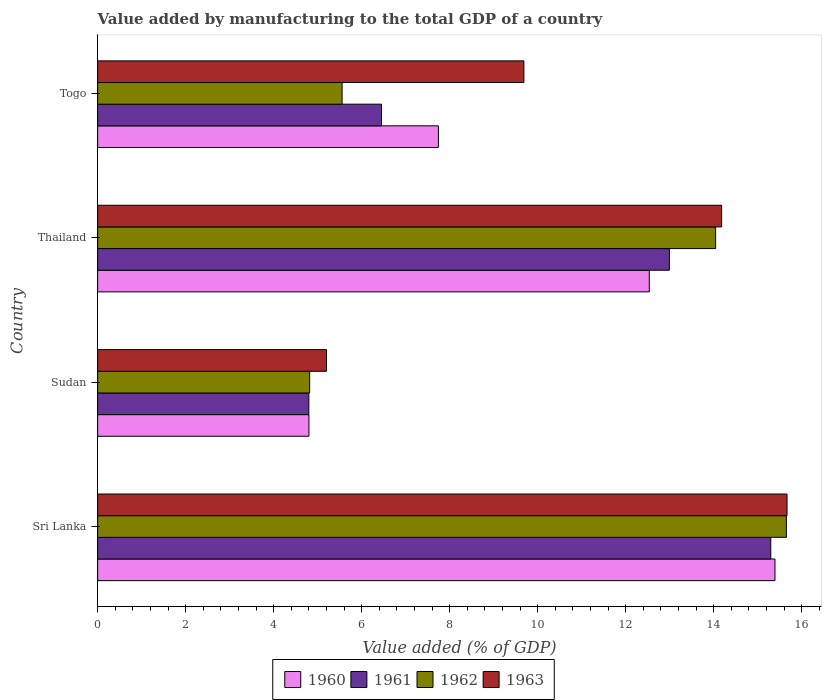How many different coloured bars are there?
Your answer should be compact. 4. Are the number of bars per tick equal to the number of legend labels?
Make the answer very short. Yes. Are the number of bars on each tick of the Y-axis equal?
Ensure brevity in your answer.  Yes. How many bars are there on the 1st tick from the top?
Offer a very short reply. 4. How many bars are there on the 4th tick from the bottom?
Give a very brief answer. 4. What is the label of the 1st group of bars from the top?
Offer a very short reply. Togo. In how many cases, is the number of bars for a given country not equal to the number of legend labels?
Keep it short and to the point. 0. What is the value added by manufacturing to the total GDP in 1960 in Sudan?
Give a very brief answer. 4.8. Across all countries, what is the maximum value added by manufacturing to the total GDP in 1963?
Offer a terse response. 15.67. Across all countries, what is the minimum value added by manufacturing to the total GDP in 1960?
Ensure brevity in your answer.  4.8. In which country was the value added by manufacturing to the total GDP in 1962 maximum?
Provide a short and direct response. Sri Lanka. In which country was the value added by manufacturing to the total GDP in 1962 minimum?
Keep it short and to the point. Sudan. What is the total value added by manufacturing to the total GDP in 1962 in the graph?
Provide a short and direct response. 40.07. What is the difference between the value added by manufacturing to the total GDP in 1963 in Sudan and that in Togo?
Ensure brevity in your answer.  -4.49. What is the difference between the value added by manufacturing to the total GDP in 1961 in Sudan and the value added by manufacturing to the total GDP in 1962 in Sri Lanka?
Make the answer very short. -10.85. What is the average value added by manufacturing to the total GDP in 1963 per country?
Keep it short and to the point. 11.18. What is the difference between the value added by manufacturing to the total GDP in 1961 and value added by manufacturing to the total GDP in 1960 in Thailand?
Your response must be concise. 0.46. In how many countries, is the value added by manufacturing to the total GDP in 1960 greater than 3.2 %?
Offer a terse response. 4. What is the ratio of the value added by manufacturing to the total GDP in 1961 in Sudan to that in Thailand?
Offer a terse response. 0.37. Is the value added by manufacturing to the total GDP in 1962 in Sri Lanka less than that in Sudan?
Ensure brevity in your answer.  No. What is the difference between the highest and the second highest value added by manufacturing to the total GDP in 1960?
Offer a terse response. 2.86. What is the difference between the highest and the lowest value added by manufacturing to the total GDP in 1960?
Make the answer very short. 10.59. In how many countries, is the value added by manufacturing to the total GDP in 1962 greater than the average value added by manufacturing to the total GDP in 1962 taken over all countries?
Your answer should be compact. 2. Is the sum of the value added by manufacturing to the total GDP in 1961 in Sri Lanka and Sudan greater than the maximum value added by manufacturing to the total GDP in 1960 across all countries?
Provide a succinct answer. Yes. Is it the case that in every country, the sum of the value added by manufacturing to the total GDP in 1962 and value added by manufacturing to the total GDP in 1960 is greater than the sum of value added by manufacturing to the total GDP in 1961 and value added by manufacturing to the total GDP in 1963?
Provide a short and direct response. No. What does the 4th bar from the top in Togo represents?
Make the answer very short. 1960. What does the 3rd bar from the bottom in Sri Lanka represents?
Your answer should be very brief. 1962. Is it the case that in every country, the sum of the value added by manufacturing to the total GDP in 1963 and value added by manufacturing to the total GDP in 1961 is greater than the value added by manufacturing to the total GDP in 1960?
Provide a short and direct response. Yes. How many countries are there in the graph?
Your answer should be very brief. 4. What is the difference between two consecutive major ticks on the X-axis?
Your answer should be very brief. 2. Does the graph contain any zero values?
Provide a short and direct response. No. How many legend labels are there?
Provide a succinct answer. 4. What is the title of the graph?
Your response must be concise. Value added by manufacturing to the total GDP of a country. What is the label or title of the X-axis?
Your response must be concise. Value added (% of GDP). What is the label or title of the Y-axis?
Ensure brevity in your answer.  Country. What is the Value added (% of GDP) in 1960 in Sri Lanka?
Give a very brief answer. 15.39. What is the Value added (% of GDP) of 1961 in Sri Lanka?
Ensure brevity in your answer.  15.3. What is the Value added (% of GDP) of 1962 in Sri Lanka?
Offer a very short reply. 15.65. What is the Value added (% of GDP) of 1963 in Sri Lanka?
Your answer should be compact. 15.67. What is the Value added (% of GDP) in 1960 in Sudan?
Your answer should be very brief. 4.8. What is the Value added (% of GDP) of 1961 in Sudan?
Your answer should be compact. 4.8. What is the Value added (% of GDP) in 1962 in Sudan?
Offer a terse response. 4.82. What is the Value added (% of GDP) in 1963 in Sudan?
Offer a terse response. 5.2. What is the Value added (% of GDP) in 1960 in Thailand?
Provide a short and direct response. 12.54. What is the Value added (% of GDP) of 1961 in Thailand?
Provide a short and direct response. 12.99. What is the Value added (% of GDP) of 1962 in Thailand?
Offer a terse response. 14.04. What is the Value added (% of GDP) in 1963 in Thailand?
Provide a succinct answer. 14.18. What is the Value added (% of GDP) in 1960 in Togo?
Offer a very short reply. 7.74. What is the Value added (% of GDP) of 1961 in Togo?
Your answer should be very brief. 6.45. What is the Value added (% of GDP) in 1962 in Togo?
Make the answer very short. 5.56. What is the Value added (% of GDP) in 1963 in Togo?
Your response must be concise. 9.69. Across all countries, what is the maximum Value added (% of GDP) of 1960?
Provide a succinct answer. 15.39. Across all countries, what is the maximum Value added (% of GDP) of 1961?
Offer a very short reply. 15.3. Across all countries, what is the maximum Value added (% of GDP) of 1962?
Ensure brevity in your answer.  15.65. Across all countries, what is the maximum Value added (% of GDP) in 1963?
Offer a terse response. 15.67. Across all countries, what is the minimum Value added (% of GDP) in 1960?
Provide a succinct answer. 4.8. Across all countries, what is the minimum Value added (% of GDP) in 1961?
Provide a succinct answer. 4.8. Across all countries, what is the minimum Value added (% of GDP) of 1962?
Offer a terse response. 4.82. Across all countries, what is the minimum Value added (% of GDP) in 1963?
Offer a very short reply. 5.2. What is the total Value added (% of GDP) in 1960 in the graph?
Your answer should be compact. 40.48. What is the total Value added (% of GDP) in 1961 in the graph?
Offer a very short reply. 39.54. What is the total Value added (% of GDP) in 1962 in the graph?
Give a very brief answer. 40.07. What is the total Value added (% of GDP) of 1963 in the graph?
Offer a terse response. 44.74. What is the difference between the Value added (% of GDP) in 1960 in Sri Lanka and that in Sudan?
Keep it short and to the point. 10.59. What is the difference between the Value added (% of GDP) in 1961 in Sri Lanka and that in Sudan?
Your answer should be very brief. 10.5. What is the difference between the Value added (% of GDP) in 1962 in Sri Lanka and that in Sudan?
Your response must be concise. 10.83. What is the difference between the Value added (% of GDP) in 1963 in Sri Lanka and that in Sudan?
Keep it short and to the point. 10.47. What is the difference between the Value added (% of GDP) of 1960 in Sri Lanka and that in Thailand?
Keep it short and to the point. 2.86. What is the difference between the Value added (% of GDP) in 1961 in Sri Lanka and that in Thailand?
Offer a very short reply. 2.3. What is the difference between the Value added (% of GDP) of 1962 in Sri Lanka and that in Thailand?
Provide a succinct answer. 1.61. What is the difference between the Value added (% of GDP) in 1963 in Sri Lanka and that in Thailand?
Keep it short and to the point. 1.49. What is the difference between the Value added (% of GDP) in 1960 in Sri Lanka and that in Togo?
Your answer should be very brief. 7.65. What is the difference between the Value added (% of GDP) in 1961 in Sri Lanka and that in Togo?
Offer a very short reply. 8.85. What is the difference between the Value added (% of GDP) in 1962 in Sri Lanka and that in Togo?
Offer a very short reply. 10.1. What is the difference between the Value added (% of GDP) of 1963 in Sri Lanka and that in Togo?
Offer a very short reply. 5.98. What is the difference between the Value added (% of GDP) in 1960 in Sudan and that in Thailand?
Make the answer very short. -7.73. What is the difference between the Value added (% of GDP) of 1961 in Sudan and that in Thailand?
Your answer should be compact. -8.19. What is the difference between the Value added (% of GDP) in 1962 in Sudan and that in Thailand?
Provide a short and direct response. -9.23. What is the difference between the Value added (% of GDP) of 1963 in Sudan and that in Thailand?
Your response must be concise. -8.98. What is the difference between the Value added (% of GDP) of 1960 in Sudan and that in Togo?
Your response must be concise. -2.94. What is the difference between the Value added (% of GDP) in 1961 in Sudan and that in Togo?
Ensure brevity in your answer.  -1.65. What is the difference between the Value added (% of GDP) of 1962 in Sudan and that in Togo?
Give a very brief answer. -0.74. What is the difference between the Value added (% of GDP) of 1963 in Sudan and that in Togo?
Your answer should be very brief. -4.49. What is the difference between the Value added (% of GDP) of 1960 in Thailand and that in Togo?
Provide a succinct answer. 4.79. What is the difference between the Value added (% of GDP) in 1961 in Thailand and that in Togo?
Your answer should be compact. 6.54. What is the difference between the Value added (% of GDP) in 1962 in Thailand and that in Togo?
Provide a short and direct response. 8.49. What is the difference between the Value added (% of GDP) in 1963 in Thailand and that in Togo?
Your response must be concise. 4.49. What is the difference between the Value added (% of GDP) of 1960 in Sri Lanka and the Value added (% of GDP) of 1961 in Sudan?
Keep it short and to the point. 10.59. What is the difference between the Value added (% of GDP) in 1960 in Sri Lanka and the Value added (% of GDP) in 1962 in Sudan?
Your answer should be compact. 10.57. What is the difference between the Value added (% of GDP) in 1960 in Sri Lanka and the Value added (% of GDP) in 1963 in Sudan?
Your answer should be compact. 10.19. What is the difference between the Value added (% of GDP) in 1961 in Sri Lanka and the Value added (% of GDP) in 1962 in Sudan?
Offer a very short reply. 10.48. What is the difference between the Value added (% of GDP) in 1961 in Sri Lanka and the Value added (% of GDP) in 1963 in Sudan?
Your response must be concise. 10.1. What is the difference between the Value added (% of GDP) of 1962 in Sri Lanka and the Value added (% of GDP) of 1963 in Sudan?
Ensure brevity in your answer.  10.45. What is the difference between the Value added (% of GDP) in 1960 in Sri Lanka and the Value added (% of GDP) in 1961 in Thailand?
Your response must be concise. 2.4. What is the difference between the Value added (% of GDP) in 1960 in Sri Lanka and the Value added (% of GDP) in 1962 in Thailand?
Your response must be concise. 1.35. What is the difference between the Value added (% of GDP) of 1960 in Sri Lanka and the Value added (% of GDP) of 1963 in Thailand?
Your answer should be compact. 1.21. What is the difference between the Value added (% of GDP) of 1961 in Sri Lanka and the Value added (% of GDP) of 1962 in Thailand?
Provide a short and direct response. 1.25. What is the difference between the Value added (% of GDP) in 1961 in Sri Lanka and the Value added (% of GDP) in 1963 in Thailand?
Ensure brevity in your answer.  1.12. What is the difference between the Value added (% of GDP) of 1962 in Sri Lanka and the Value added (% of GDP) of 1963 in Thailand?
Offer a very short reply. 1.47. What is the difference between the Value added (% of GDP) of 1960 in Sri Lanka and the Value added (% of GDP) of 1961 in Togo?
Your answer should be very brief. 8.94. What is the difference between the Value added (% of GDP) in 1960 in Sri Lanka and the Value added (% of GDP) in 1962 in Togo?
Your response must be concise. 9.84. What is the difference between the Value added (% of GDP) in 1960 in Sri Lanka and the Value added (% of GDP) in 1963 in Togo?
Make the answer very short. 5.71. What is the difference between the Value added (% of GDP) of 1961 in Sri Lanka and the Value added (% of GDP) of 1962 in Togo?
Give a very brief answer. 9.74. What is the difference between the Value added (% of GDP) of 1961 in Sri Lanka and the Value added (% of GDP) of 1963 in Togo?
Provide a short and direct response. 5.61. What is the difference between the Value added (% of GDP) of 1962 in Sri Lanka and the Value added (% of GDP) of 1963 in Togo?
Provide a succinct answer. 5.97. What is the difference between the Value added (% of GDP) in 1960 in Sudan and the Value added (% of GDP) in 1961 in Thailand?
Offer a very short reply. -8.19. What is the difference between the Value added (% of GDP) in 1960 in Sudan and the Value added (% of GDP) in 1962 in Thailand?
Offer a terse response. -9.24. What is the difference between the Value added (% of GDP) of 1960 in Sudan and the Value added (% of GDP) of 1963 in Thailand?
Keep it short and to the point. -9.38. What is the difference between the Value added (% of GDP) in 1961 in Sudan and the Value added (% of GDP) in 1962 in Thailand?
Offer a terse response. -9.24. What is the difference between the Value added (% of GDP) in 1961 in Sudan and the Value added (% of GDP) in 1963 in Thailand?
Your response must be concise. -9.38. What is the difference between the Value added (% of GDP) in 1962 in Sudan and the Value added (% of GDP) in 1963 in Thailand?
Offer a terse response. -9.36. What is the difference between the Value added (% of GDP) in 1960 in Sudan and the Value added (% of GDP) in 1961 in Togo?
Ensure brevity in your answer.  -1.65. What is the difference between the Value added (% of GDP) of 1960 in Sudan and the Value added (% of GDP) of 1962 in Togo?
Your response must be concise. -0.75. What is the difference between the Value added (% of GDP) in 1960 in Sudan and the Value added (% of GDP) in 1963 in Togo?
Give a very brief answer. -4.88. What is the difference between the Value added (% of GDP) of 1961 in Sudan and the Value added (% of GDP) of 1962 in Togo?
Your answer should be compact. -0.76. What is the difference between the Value added (% of GDP) in 1961 in Sudan and the Value added (% of GDP) in 1963 in Togo?
Offer a terse response. -4.89. What is the difference between the Value added (% of GDP) in 1962 in Sudan and the Value added (% of GDP) in 1963 in Togo?
Your response must be concise. -4.87. What is the difference between the Value added (% of GDP) in 1960 in Thailand and the Value added (% of GDP) in 1961 in Togo?
Offer a terse response. 6.09. What is the difference between the Value added (% of GDP) of 1960 in Thailand and the Value added (% of GDP) of 1962 in Togo?
Offer a terse response. 6.98. What is the difference between the Value added (% of GDP) of 1960 in Thailand and the Value added (% of GDP) of 1963 in Togo?
Offer a very short reply. 2.85. What is the difference between the Value added (% of GDP) of 1961 in Thailand and the Value added (% of GDP) of 1962 in Togo?
Your answer should be very brief. 7.44. What is the difference between the Value added (% of GDP) of 1961 in Thailand and the Value added (% of GDP) of 1963 in Togo?
Provide a short and direct response. 3.31. What is the difference between the Value added (% of GDP) in 1962 in Thailand and the Value added (% of GDP) in 1963 in Togo?
Offer a very short reply. 4.36. What is the average Value added (% of GDP) in 1960 per country?
Provide a succinct answer. 10.12. What is the average Value added (% of GDP) in 1961 per country?
Ensure brevity in your answer.  9.89. What is the average Value added (% of GDP) of 1962 per country?
Offer a terse response. 10.02. What is the average Value added (% of GDP) of 1963 per country?
Provide a succinct answer. 11.18. What is the difference between the Value added (% of GDP) in 1960 and Value added (% of GDP) in 1961 in Sri Lanka?
Give a very brief answer. 0.1. What is the difference between the Value added (% of GDP) of 1960 and Value added (% of GDP) of 1962 in Sri Lanka?
Provide a succinct answer. -0.26. What is the difference between the Value added (% of GDP) in 1960 and Value added (% of GDP) in 1963 in Sri Lanka?
Provide a succinct answer. -0.27. What is the difference between the Value added (% of GDP) of 1961 and Value added (% of GDP) of 1962 in Sri Lanka?
Your answer should be compact. -0.35. What is the difference between the Value added (% of GDP) in 1961 and Value added (% of GDP) in 1963 in Sri Lanka?
Give a very brief answer. -0.37. What is the difference between the Value added (% of GDP) in 1962 and Value added (% of GDP) in 1963 in Sri Lanka?
Make the answer very short. -0.01. What is the difference between the Value added (% of GDP) of 1960 and Value added (% of GDP) of 1961 in Sudan?
Keep it short and to the point. 0. What is the difference between the Value added (% of GDP) in 1960 and Value added (% of GDP) in 1962 in Sudan?
Give a very brief answer. -0.02. What is the difference between the Value added (% of GDP) in 1960 and Value added (% of GDP) in 1963 in Sudan?
Your answer should be very brief. -0.4. What is the difference between the Value added (% of GDP) of 1961 and Value added (% of GDP) of 1962 in Sudan?
Your response must be concise. -0.02. What is the difference between the Value added (% of GDP) of 1961 and Value added (% of GDP) of 1963 in Sudan?
Your response must be concise. -0.4. What is the difference between the Value added (% of GDP) of 1962 and Value added (% of GDP) of 1963 in Sudan?
Your response must be concise. -0.38. What is the difference between the Value added (% of GDP) in 1960 and Value added (% of GDP) in 1961 in Thailand?
Provide a succinct answer. -0.46. What is the difference between the Value added (% of GDP) in 1960 and Value added (% of GDP) in 1962 in Thailand?
Offer a very short reply. -1.51. What is the difference between the Value added (% of GDP) in 1960 and Value added (% of GDP) in 1963 in Thailand?
Provide a short and direct response. -1.64. What is the difference between the Value added (% of GDP) in 1961 and Value added (% of GDP) in 1962 in Thailand?
Offer a terse response. -1.05. What is the difference between the Value added (% of GDP) in 1961 and Value added (% of GDP) in 1963 in Thailand?
Your response must be concise. -1.19. What is the difference between the Value added (% of GDP) in 1962 and Value added (% of GDP) in 1963 in Thailand?
Give a very brief answer. -0.14. What is the difference between the Value added (% of GDP) of 1960 and Value added (% of GDP) of 1961 in Togo?
Your answer should be very brief. 1.29. What is the difference between the Value added (% of GDP) of 1960 and Value added (% of GDP) of 1962 in Togo?
Keep it short and to the point. 2.19. What is the difference between the Value added (% of GDP) in 1960 and Value added (% of GDP) in 1963 in Togo?
Offer a terse response. -1.94. What is the difference between the Value added (% of GDP) in 1961 and Value added (% of GDP) in 1962 in Togo?
Offer a terse response. 0.9. What is the difference between the Value added (% of GDP) of 1961 and Value added (% of GDP) of 1963 in Togo?
Give a very brief answer. -3.23. What is the difference between the Value added (% of GDP) of 1962 and Value added (% of GDP) of 1963 in Togo?
Keep it short and to the point. -4.13. What is the ratio of the Value added (% of GDP) in 1960 in Sri Lanka to that in Sudan?
Your answer should be very brief. 3.21. What is the ratio of the Value added (% of GDP) of 1961 in Sri Lanka to that in Sudan?
Keep it short and to the point. 3.19. What is the ratio of the Value added (% of GDP) of 1962 in Sri Lanka to that in Sudan?
Ensure brevity in your answer.  3.25. What is the ratio of the Value added (% of GDP) in 1963 in Sri Lanka to that in Sudan?
Offer a terse response. 3.01. What is the ratio of the Value added (% of GDP) of 1960 in Sri Lanka to that in Thailand?
Provide a short and direct response. 1.23. What is the ratio of the Value added (% of GDP) in 1961 in Sri Lanka to that in Thailand?
Offer a very short reply. 1.18. What is the ratio of the Value added (% of GDP) of 1962 in Sri Lanka to that in Thailand?
Provide a short and direct response. 1.11. What is the ratio of the Value added (% of GDP) of 1963 in Sri Lanka to that in Thailand?
Provide a succinct answer. 1.1. What is the ratio of the Value added (% of GDP) in 1960 in Sri Lanka to that in Togo?
Offer a very short reply. 1.99. What is the ratio of the Value added (% of GDP) of 1961 in Sri Lanka to that in Togo?
Your answer should be very brief. 2.37. What is the ratio of the Value added (% of GDP) in 1962 in Sri Lanka to that in Togo?
Your answer should be compact. 2.82. What is the ratio of the Value added (% of GDP) of 1963 in Sri Lanka to that in Togo?
Your answer should be compact. 1.62. What is the ratio of the Value added (% of GDP) in 1960 in Sudan to that in Thailand?
Give a very brief answer. 0.38. What is the ratio of the Value added (% of GDP) of 1961 in Sudan to that in Thailand?
Make the answer very short. 0.37. What is the ratio of the Value added (% of GDP) of 1962 in Sudan to that in Thailand?
Provide a short and direct response. 0.34. What is the ratio of the Value added (% of GDP) of 1963 in Sudan to that in Thailand?
Offer a very short reply. 0.37. What is the ratio of the Value added (% of GDP) in 1960 in Sudan to that in Togo?
Keep it short and to the point. 0.62. What is the ratio of the Value added (% of GDP) in 1961 in Sudan to that in Togo?
Provide a short and direct response. 0.74. What is the ratio of the Value added (% of GDP) in 1962 in Sudan to that in Togo?
Give a very brief answer. 0.87. What is the ratio of the Value added (% of GDP) in 1963 in Sudan to that in Togo?
Offer a terse response. 0.54. What is the ratio of the Value added (% of GDP) of 1960 in Thailand to that in Togo?
Offer a terse response. 1.62. What is the ratio of the Value added (% of GDP) in 1961 in Thailand to that in Togo?
Make the answer very short. 2.01. What is the ratio of the Value added (% of GDP) in 1962 in Thailand to that in Togo?
Your answer should be very brief. 2.53. What is the ratio of the Value added (% of GDP) in 1963 in Thailand to that in Togo?
Keep it short and to the point. 1.46. What is the difference between the highest and the second highest Value added (% of GDP) of 1960?
Offer a very short reply. 2.86. What is the difference between the highest and the second highest Value added (% of GDP) of 1961?
Provide a short and direct response. 2.3. What is the difference between the highest and the second highest Value added (% of GDP) in 1962?
Offer a very short reply. 1.61. What is the difference between the highest and the second highest Value added (% of GDP) in 1963?
Your answer should be very brief. 1.49. What is the difference between the highest and the lowest Value added (% of GDP) in 1960?
Provide a succinct answer. 10.59. What is the difference between the highest and the lowest Value added (% of GDP) of 1961?
Provide a succinct answer. 10.5. What is the difference between the highest and the lowest Value added (% of GDP) of 1962?
Your answer should be very brief. 10.83. What is the difference between the highest and the lowest Value added (% of GDP) of 1963?
Your answer should be compact. 10.47. 